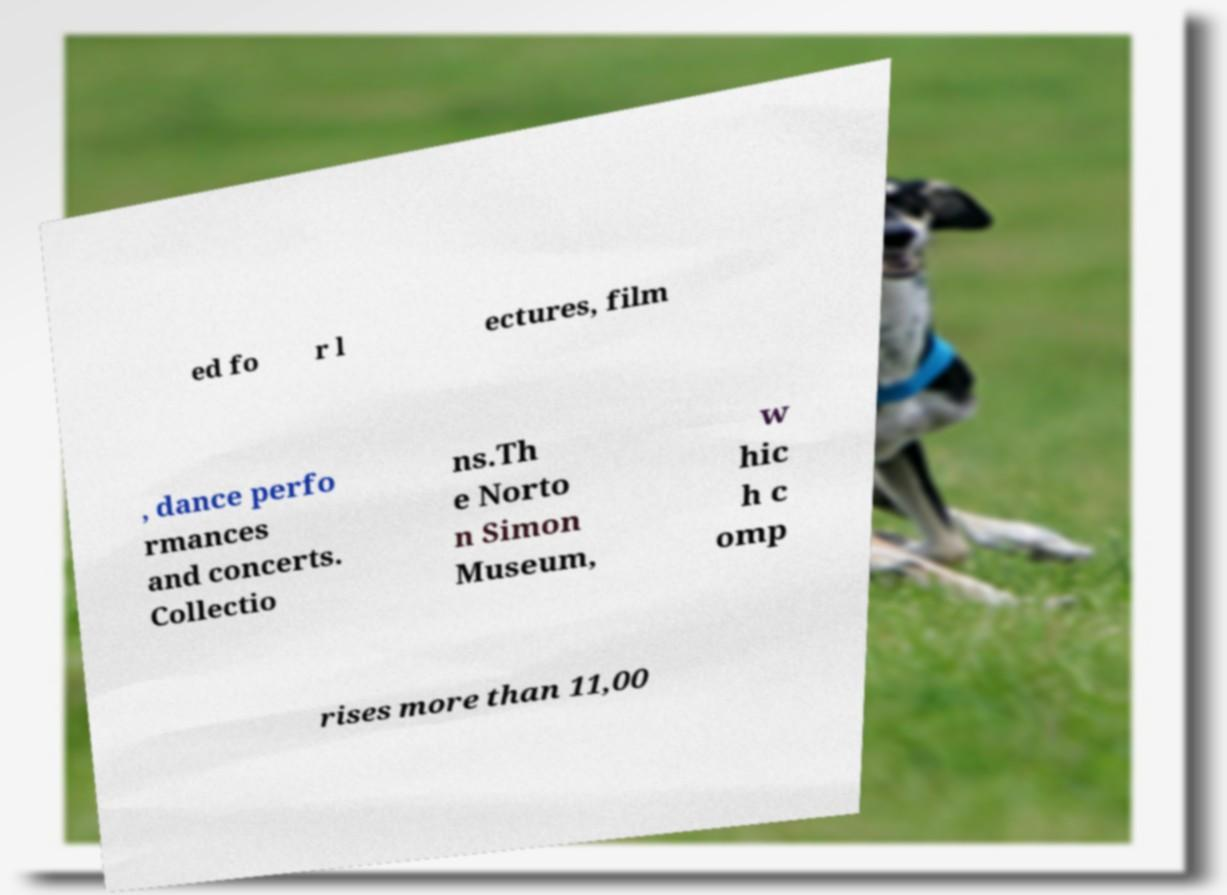Can you accurately transcribe the text from the provided image for me? ed fo r l ectures, film , dance perfo rmances and concerts. Collectio ns.Th e Norto n Simon Museum, w hic h c omp rises more than 11,00 